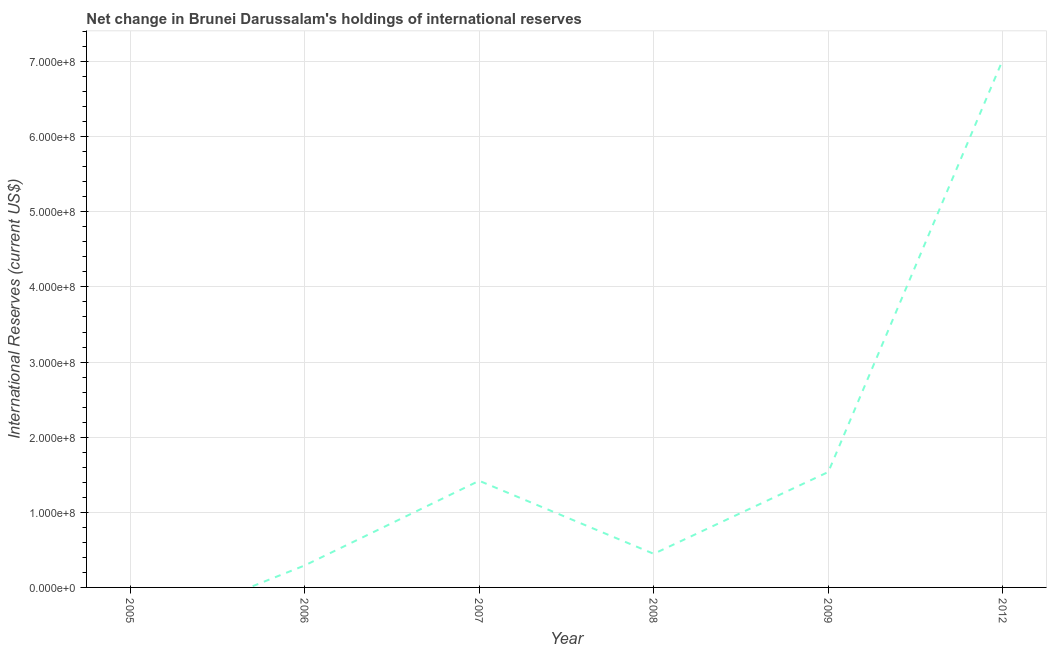What is the reserves and related items in 2012?
Your response must be concise. 7.03e+08. Across all years, what is the maximum reserves and related items?
Your response must be concise. 7.03e+08. Across all years, what is the minimum reserves and related items?
Your response must be concise. 0. In which year was the reserves and related items maximum?
Make the answer very short. 2012. What is the sum of the reserves and related items?
Your answer should be very brief. 1.07e+09. What is the difference between the reserves and related items in 2007 and 2008?
Give a very brief answer. 9.72e+07. What is the average reserves and related items per year?
Offer a terse response. 1.79e+08. What is the median reserves and related items?
Your answer should be very brief. 9.33e+07. In how many years, is the reserves and related items greater than 60000000 US$?
Give a very brief answer. 3. What is the ratio of the reserves and related items in 2006 to that in 2009?
Offer a very short reply. 0.19. What is the difference between the highest and the second highest reserves and related items?
Offer a very short reply. 5.49e+08. What is the difference between the highest and the lowest reserves and related items?
Provide a short and direct response. 7.03e+08. In how many years, is the reserves and related items greater than the average reserves and related items taken over all years?
Ensure brevity in your answer.  1. Does the reserves and related items monotonically increase over the years?
Give a very brief answer. No. Are the values on the major ticks of Y-axis written in scientific E-notation?
Ensure brevity in your answer.  Yes. What is the title of the graph?
Offer a terse response. Net change in Brunei Darussalam's holdings of international reserves. What is the label or title of the X-axis?
Offer a very short reply. Year. What is the label or title of the Y-axis?
Keep it short and to the point. International Reserves (current US$). What is the International Reserves (current US$) of 2005?
Your answer should be very brief. 0. What is the International Reserves (current US$) of 2006?
Your response must be concise. 2.92e+07. What is the International Reserves (current US$) in 2007?
Offer a very short reply. 1.42e+08. What is the International Reserves (current US$) in 2008?
Offer a terse response. 4.47e+07. What is the International Reserves (current US$) in 2009?
Your answer should be very brief. 1.54e+08. What is the International Reserves (current US$) of 2012?
Give a very brief answer. 7.03e+08. What is the difference between the International Reserves (current US$) in 2006 and 2007?
Ensure brevity in your answer.  -1.13e+08. What is the difference between the International Reserves (current US$) in 2006 and 2008?
Ensure brevity in your answer.  -1.55e+07. What is the difference between the International Reserves (current US$) in 2006 and 2009?
Keep it short and to the point. -1.24e+08. What is the difference between the International Reserves (current US$) in 2006 and 2012?
Make the answer very short. -6.73e+08. What is the difference between the International Reserves (current US$) in 2007 and 2008?
Offer a terse response. 9.72e+07. What is the difference between the International Reserves (current US$) in 2007 and 2009?
Your answer should be very brief. -1.17e+07. What is the difference between the International Reserves (current US$) in 2007 and 2012?
Offer a terse response. -5.61e+08. What is the difference between the International Reserves (current US$) in 2008 and 2009?
Provide a succinct answer. -1.09e+08. What is the difference between the International Reserves (current US$) in 2008 and 2012?
Keep it short and to the point. -6.58e+08. What is the difference between the International Reserves (current US$) in 2009 and 2012?
Provide a short and direct response. -5.49e+08. What is the ratio of the International Reserves (current US$) in 2006 to that in 2007?
Make the answer very short. 0.21. What is the ratio of the International Reserves (current US$) in 2006 to that in 2008?
Give a very brief answer. 0.65. What is the ratio of the International Reserves (current US$) in 2006 to that in 2009?
Offer a terse response. 0.19. What is the ratio of the International Reserves (current US$) in 2006 to that in 2012?
Provide a short and direct response. 0.04. What is the ratio of the International Reserves (current US$) in 2007 to that in 2008?
Your answer should be compact. 3.17. What is the ratio of the International Reserves (current US$) in 2007 to that in 2009?
Ensure brevity in your answer.  0.92. What is the ratio of the International Reserves (current US$) in 2007 to that in 2012?
Offer a very short reply. 0.2. What is the ratio of the International Reserves (current US$) in 2008 to that in 2009?
Offer a terse response. 0.29. What is the ratio of the International Reserves (current US$) in 2008 to that in 2012?
Your answer should be compact. 0.06. What is the ratio of the International Reserves (current US$) in 2009 to that in 2012?
Your response must be concise. 0.22. 